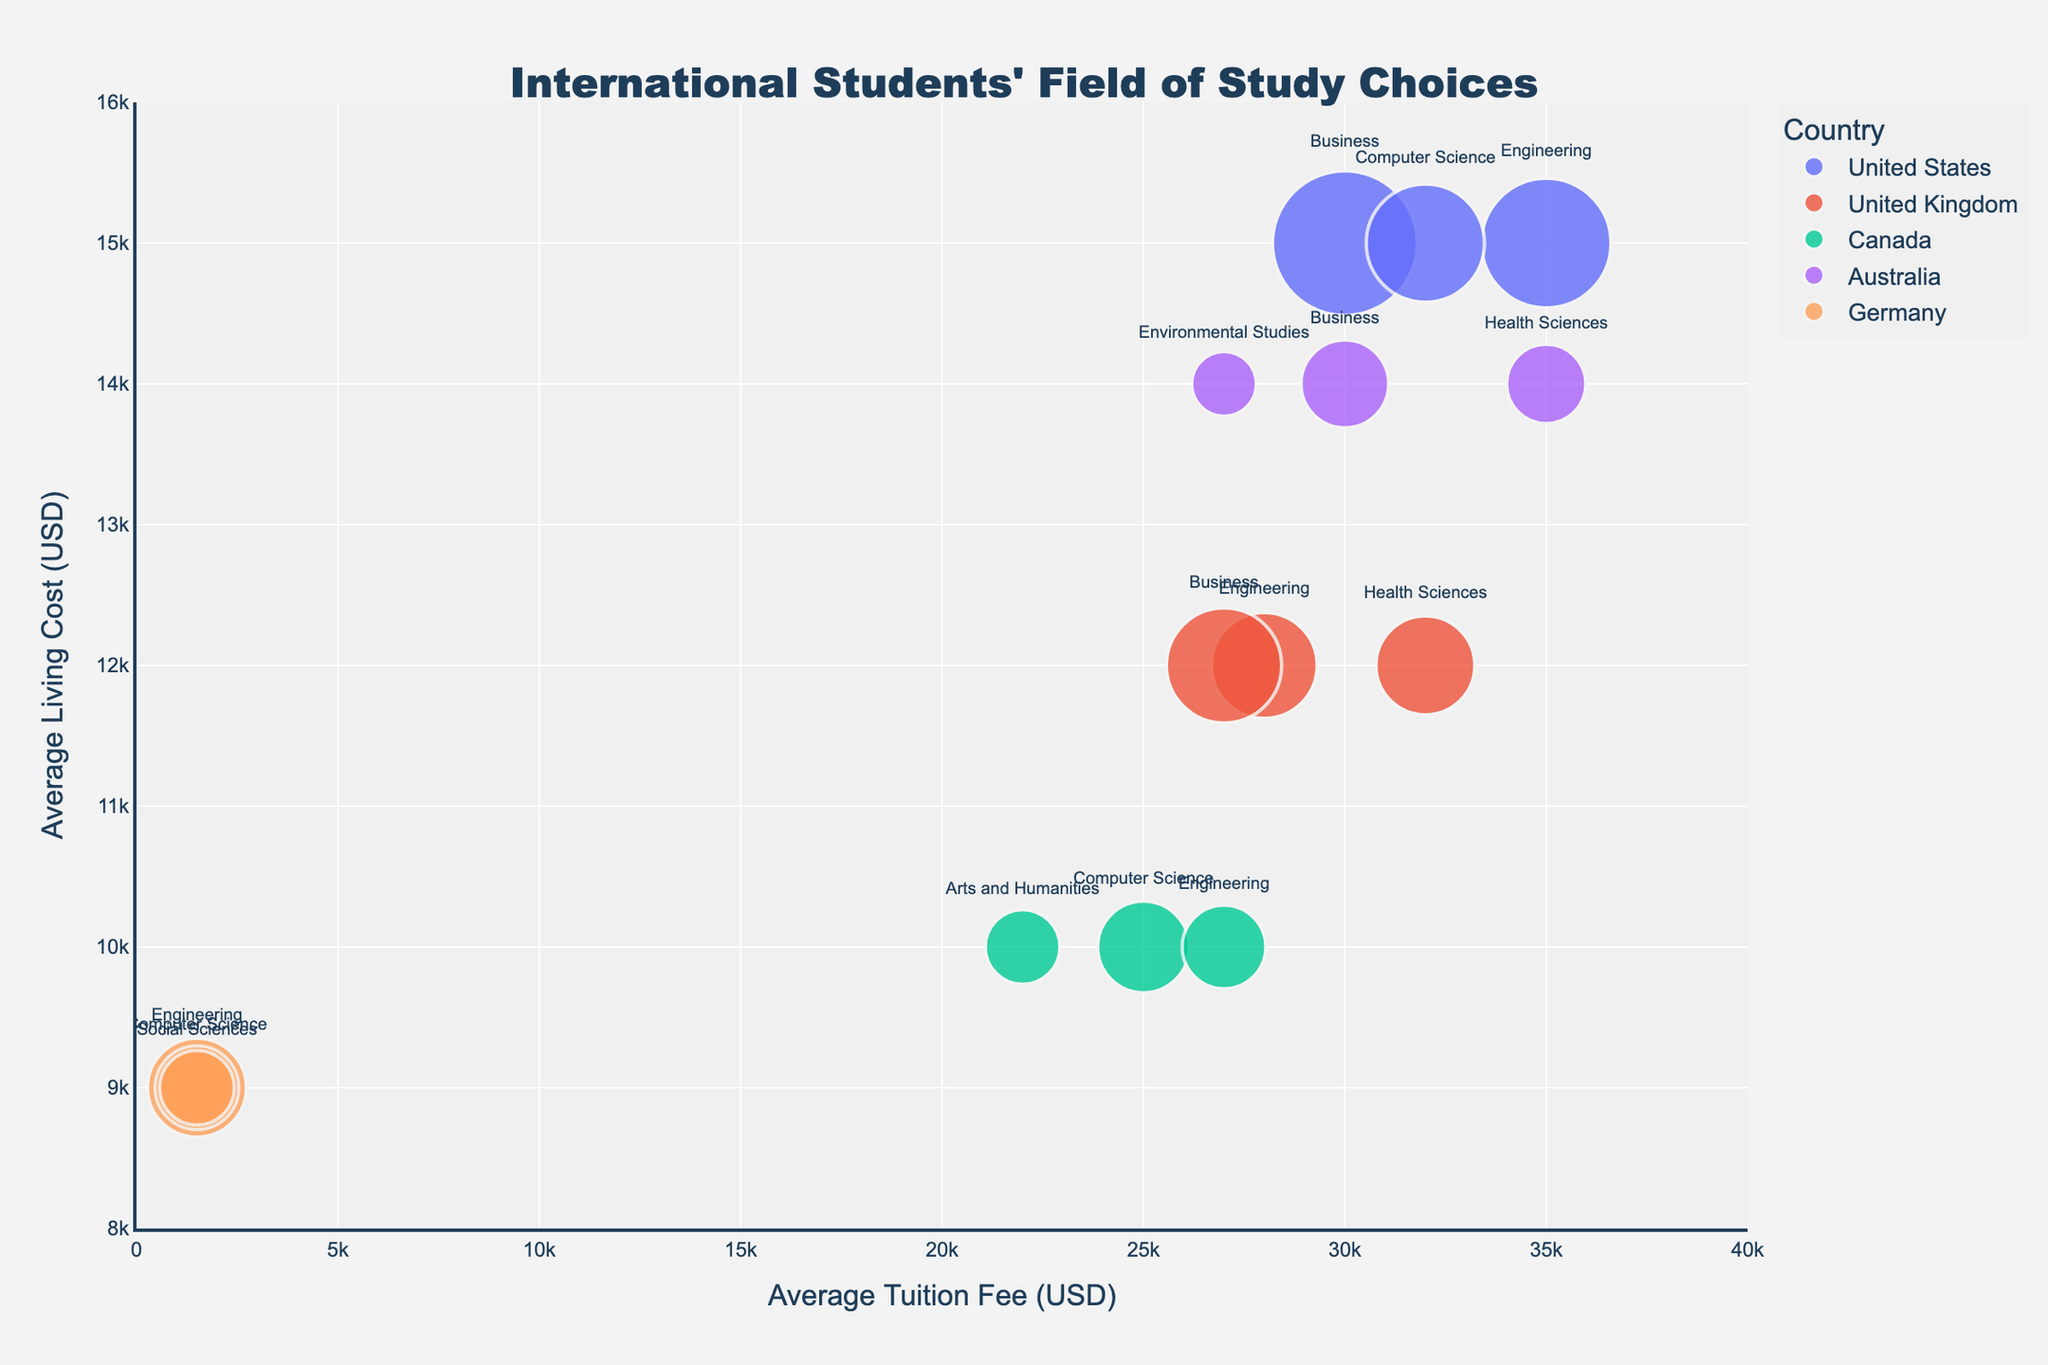What is the title of the figure? The title of the figure is located at the top center, and it reads "International Students' Field of Study Choices."
Answer: International Students' Field of Study Choices Which country has the highest number of students studying Business? By examining the bubble sizes and labels, the country with the largest bubble for Business is the United States. It has a bubble size that represents 15,000 students.
Answer: United States What is the range of the average living costs shown on the y-axis? The y-axis displays the average living costs, and the values range from 8,000 to 16,000 USD.
Answer: 8,000 to 16,000 USD Which field of study in Germany has the lowest average tuition fee? Looking at the bubbles representing Germany, the fields of study are Engineering, Computer Science, and Social Sciences. All three have an average tuition fee of 1,500 USD, making them the lowest among the options.
Answer: Engineering, Computer Science, Social Sciences Which country has the highest living cost for Health Sciences? By checking the y-axis values for Health Sciences bubbles, it's clear that Australia has the highest average living cost at 14,000 USD.
Answer: Australia What is the difference in average tuition fee for Engineering students between the United States and Germany? The tuition fee for Engineering in the United States is 35,000 USD, and for Germany, it is 1,500 USD. The difference is 35,000 - 1,500 = 33,500 USD.
Answer: 33,500 USD Which country has the most diverse selection of fields of study among international students? List out the fields per country and compare: United States (3), United Kingdom (3), Canada (3), Australia (3), Germany (3). Each listed country has students spread evenly over three different fields of study.
Answer: All listed countries How do the average living costs for Business students compare between the United Kingdom and Australia? The y-axis indicates the average living cost for Business in the United Kingdom is 12,000 USD, and in Australia, it is 14,000 USD. The cost in Australia is higher.
Answer: Australia is higher Which field of study has the largest bubble in the United Kingdom? Examining the bubbles for the United Kingdom, the largest bubble represents Business, which indicates the highest number of students (9,500).
Answer: Business Given that Australia has a high living cost for Health Sciences students, what might that imply about student distribution in Environmental Studies? The high living cost might indicate fewer students can afford Health Sciences in Australia despite the demand, evidenced by the smaller bubble for Environmental Studies. This suggests economic factors affecting distribution.
Answer: Economic factors affect distribution 